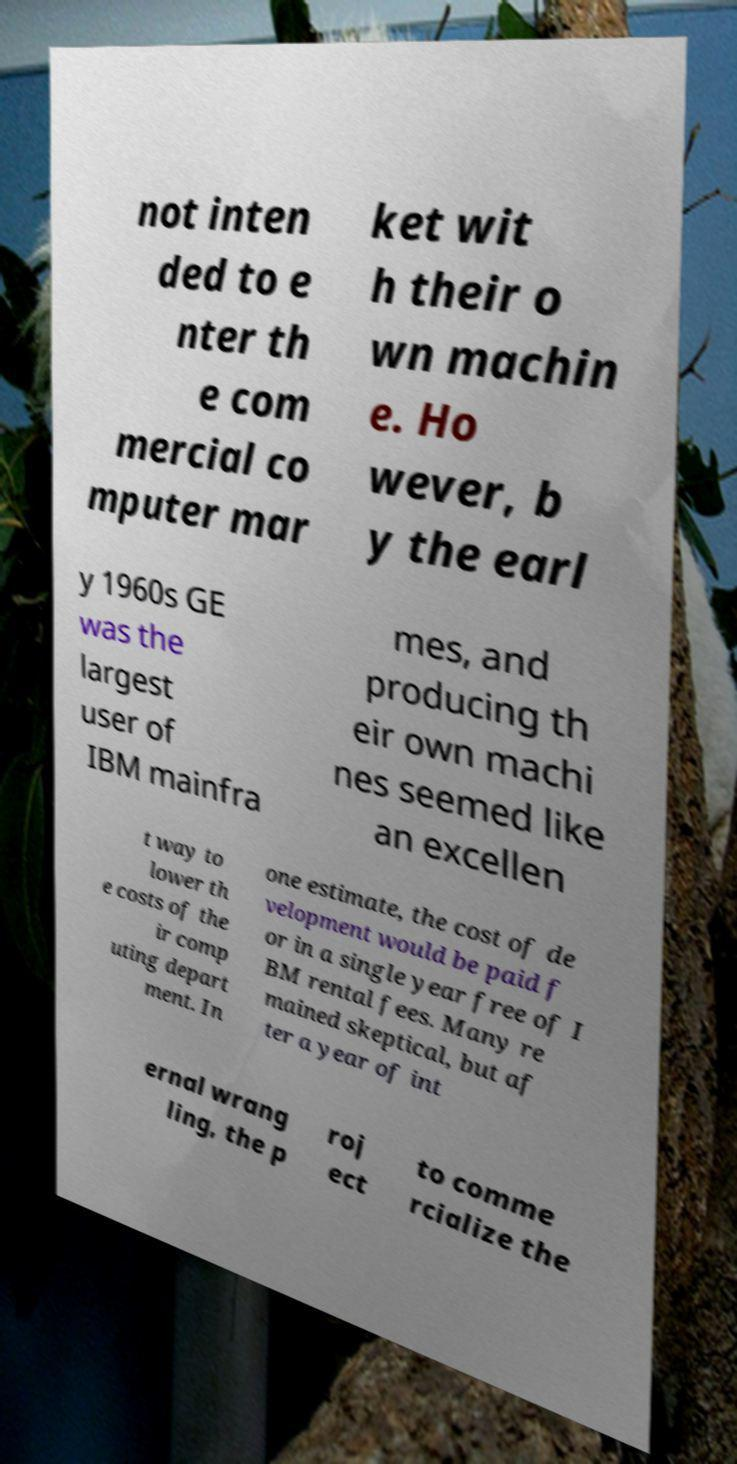Please identify and transcribe the text found in this image. not inten ded to e nter th e com mercial co mputer mar ket wit h their o wn machin e. Ho wever, b y the earl y 1960s GE was the largest user of IBM mainfra mes, and producing th eir own machi nes seemed like an excellen t way to lower th e costs of the ir comp uting depart ment. In one estimate, the cost of de velopment would be paid f or in a single year free of I BM rental fees. Many re mained skeptical, but af ter a year of int ernal wrang ling, the p roj ect to comme rcialize the 